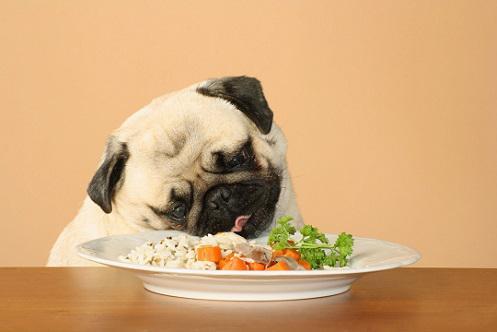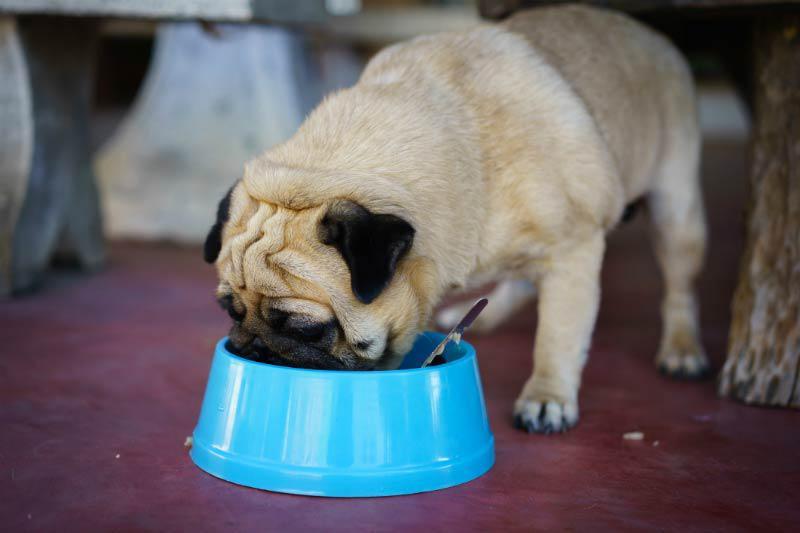The first image is the image on the left, the second image is the image on the right. For the images shown, is this caption "Atleast one picture contains a bowl with food." true? Answer yes or no. Yes. The first image is the image on the left, the second image is the image on the right. Considering the images on both sides, is "In the left image, a dog is eating some food set up for a human." valid? Answer yes or no. Yes. 